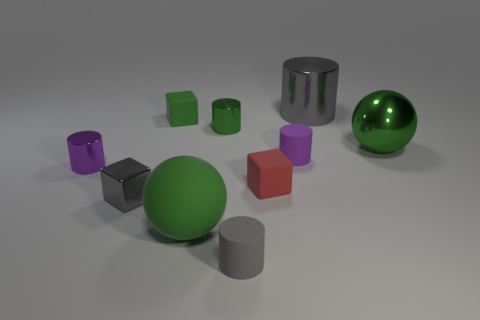Are there any tiny green rubber objects that have the same shape as the small gray rubber thing?
Provide a short and direct response. No. Are there the same number of tiny red objects that are on the left side of the gray matte thing and matte cylinders that are to the left of the purple rubber object?
Your answer should be compact. No. Are there any other things that have the same size as the red thing?
Offer a very short reply. Yes. What number of purple things are small shiny objects or big matte balls?
Your answer should be compact. 1. How many purple spheres have the same size as the purple matte object?
Keep it short and to the point. 0. What is the color of the small cylinder that is on the right side of the tiny green cylinder and behind the small metal cube?
Your answer should be compact. Purple. Are there more large shiny cylinders that are in front of the tiny red object than tiny purple metal blocks?
Ensure brevity in your answer.  No. Are any large cyan metal cubes visible?
Provide a short and direct response. No. Is the color of the big cylinder the same as the tiny shiny block?
Offer a very short reply. Yes. How many tiny objects are either purple rubber cubes or purple cylinders?
Make the answer very short. 2. 